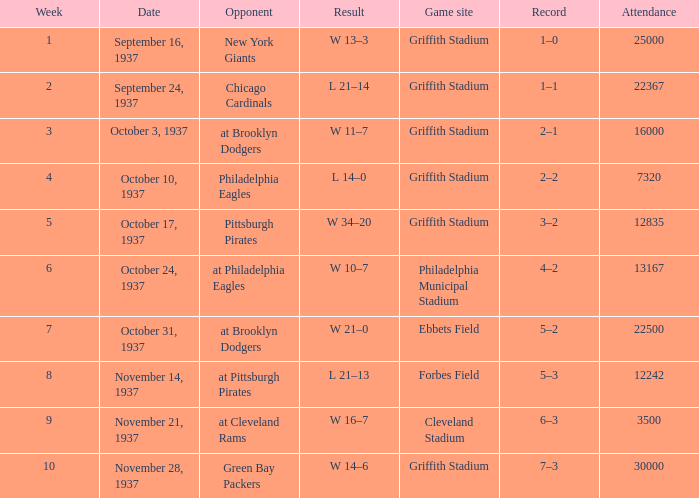On October 17, 1937 what was maximum number or attendants. 12835.0. 